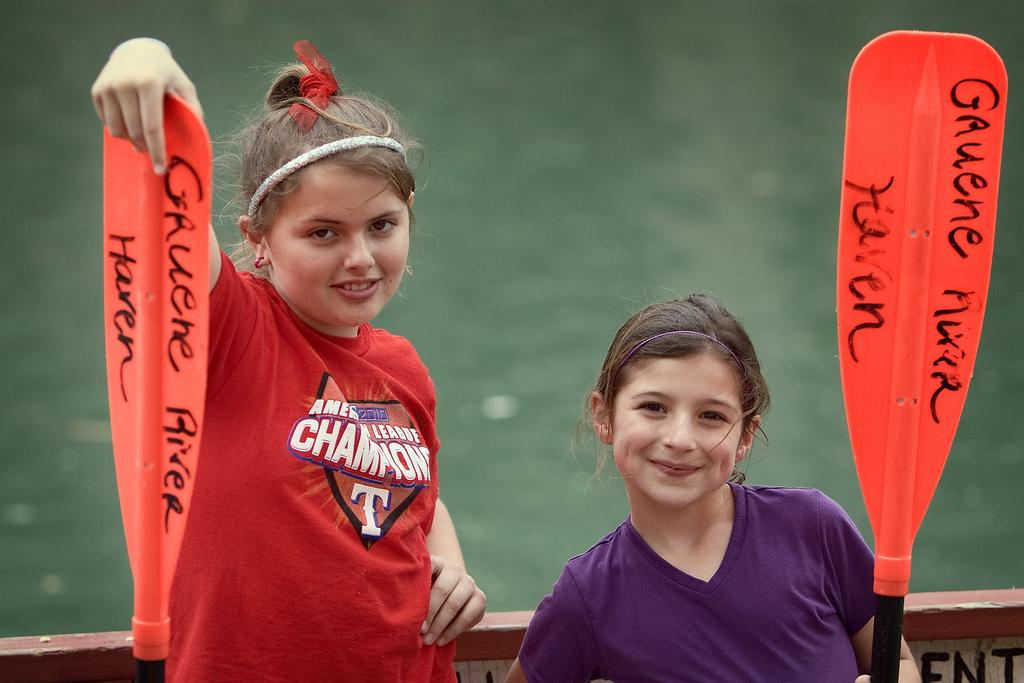Provide a one-sentence caption for the provided image. Two girls holding paddles from the Gauene River Haven. 